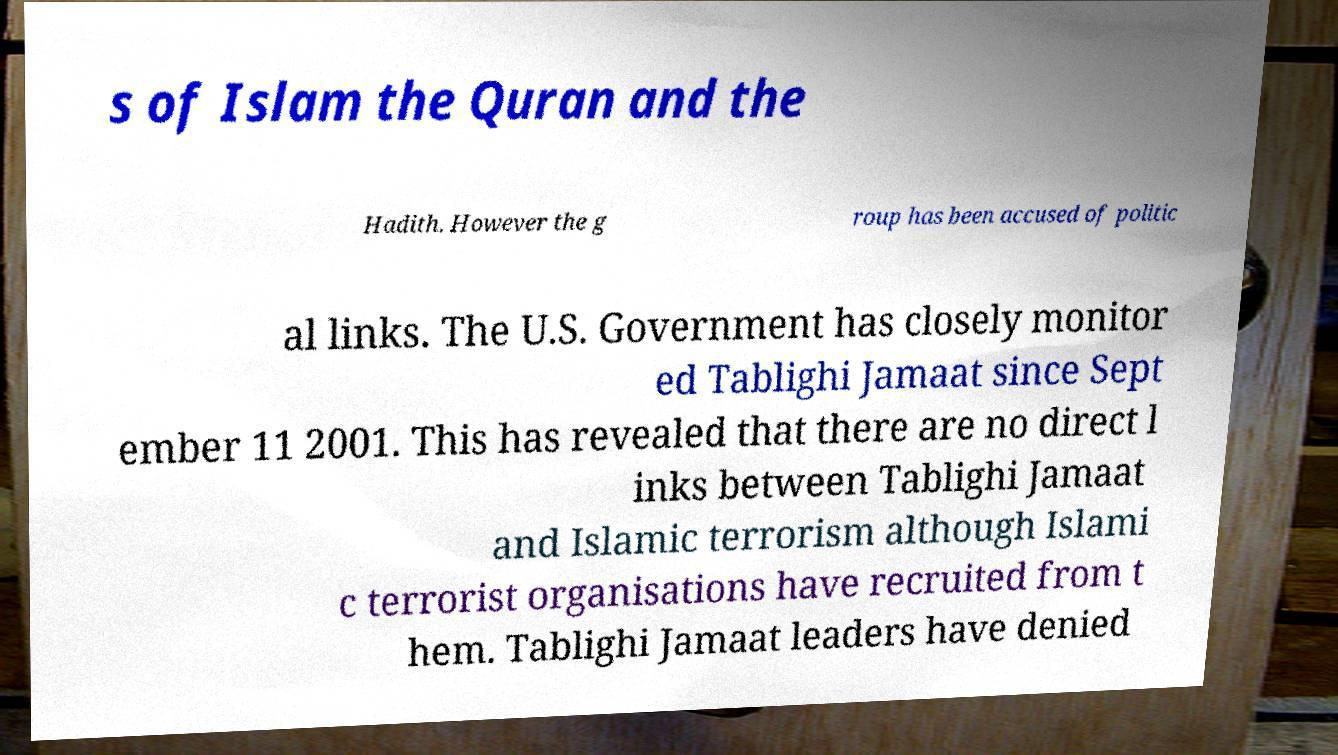Could you extract and type out the text from this image? s of Islam the Quran and the Hadith. However the g roup has been accused of politic al links. The U.S. Government has closely monitor ed Tablighi Jamaat since Sept ember 11 2001. This has revealed that there are no direct l inks between Tablighi Jamaat and Islamic terrorism although Islami c terrorist organisations have recruited from t hem. Tablighi Jamaat leaders have denied 